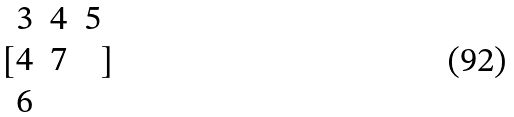<formula> <loc_0><loc_0><loc_500><loc_500>[ \begin{matrix} 3 & 4 & 5 \\ 4 & 7 \\ 6 \end{matrix} ]</formula> 